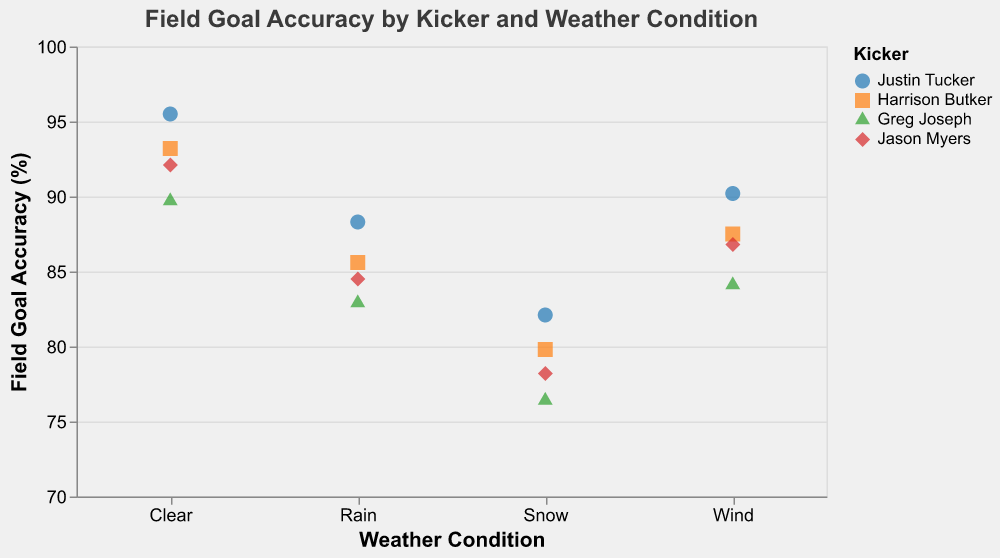How does Justin Tucker's field goal accuracy compare between clear and snowy conditions? In clear weather, Justin Tucker has an accuracy of 95.5. In snowy conditions, his accuracy drops to 82.1. The difference is 95.5 - 82.1 = 13.4.
Answer: 13.4 Which kicker has the best field goal accuracy in windy conditions? In windy conditions, Justin Tucker has the highest accuracy at 90.2.
Answer: Justin Tucker What's the general trend of field goal accuracy as weather conditions worsen from clear to snowy? Field goal accuracy tends to decrease as weather conditions worsen. For all kickers, accuracy is highest in clear weather and progressively decreases in rain, wind, and snow.
Answer: Decreases What's the average accuracy of Harrison Butker across all weather conditions? Harrison Butker's accuracies are: 93.2 (clear), 85.6 (rain), 79.8 (snow), and 87.5 (wind). Average = (93.2 + 85.6 + 79.8 + 87.5) / 4 = 86.53.
Answer: 86.53 How does Jason Myers' accuracy in rainy conditions compare to his accuracy in wind? Jason Myers' accuracy in rainy conditions is 84.5, while in windy conditions, it's 86.8. The difference is 86.8 - 84.5 = 2.3.
Answer: 2.3 Which kicker has the least variation in accuracy between the different weather conditions? Justin Tucker is most consistent with accuracies: 95.5 (clear), 88.3 (rain), 82.1 (snow), and 90.2 (wind). The range is 95.5 - 82.1 = 13.4. Compared to the ranges for other kickers, his is the smallest.
Answer: Justin Tucker What color is used to represent Greg Joseph on the plot? Greg Joseph is represented by the color green on the plot.
Answer: Green If a fan argues that Greg Joseph is the weakest kicker based on this data, would they be right? Greg Joseph consistently has the lowest accuracy in every weather condition: 89.7 (clear), 82.9 (rain), 76.4 (snow), 84.1 (wind).
Answer: Yes 